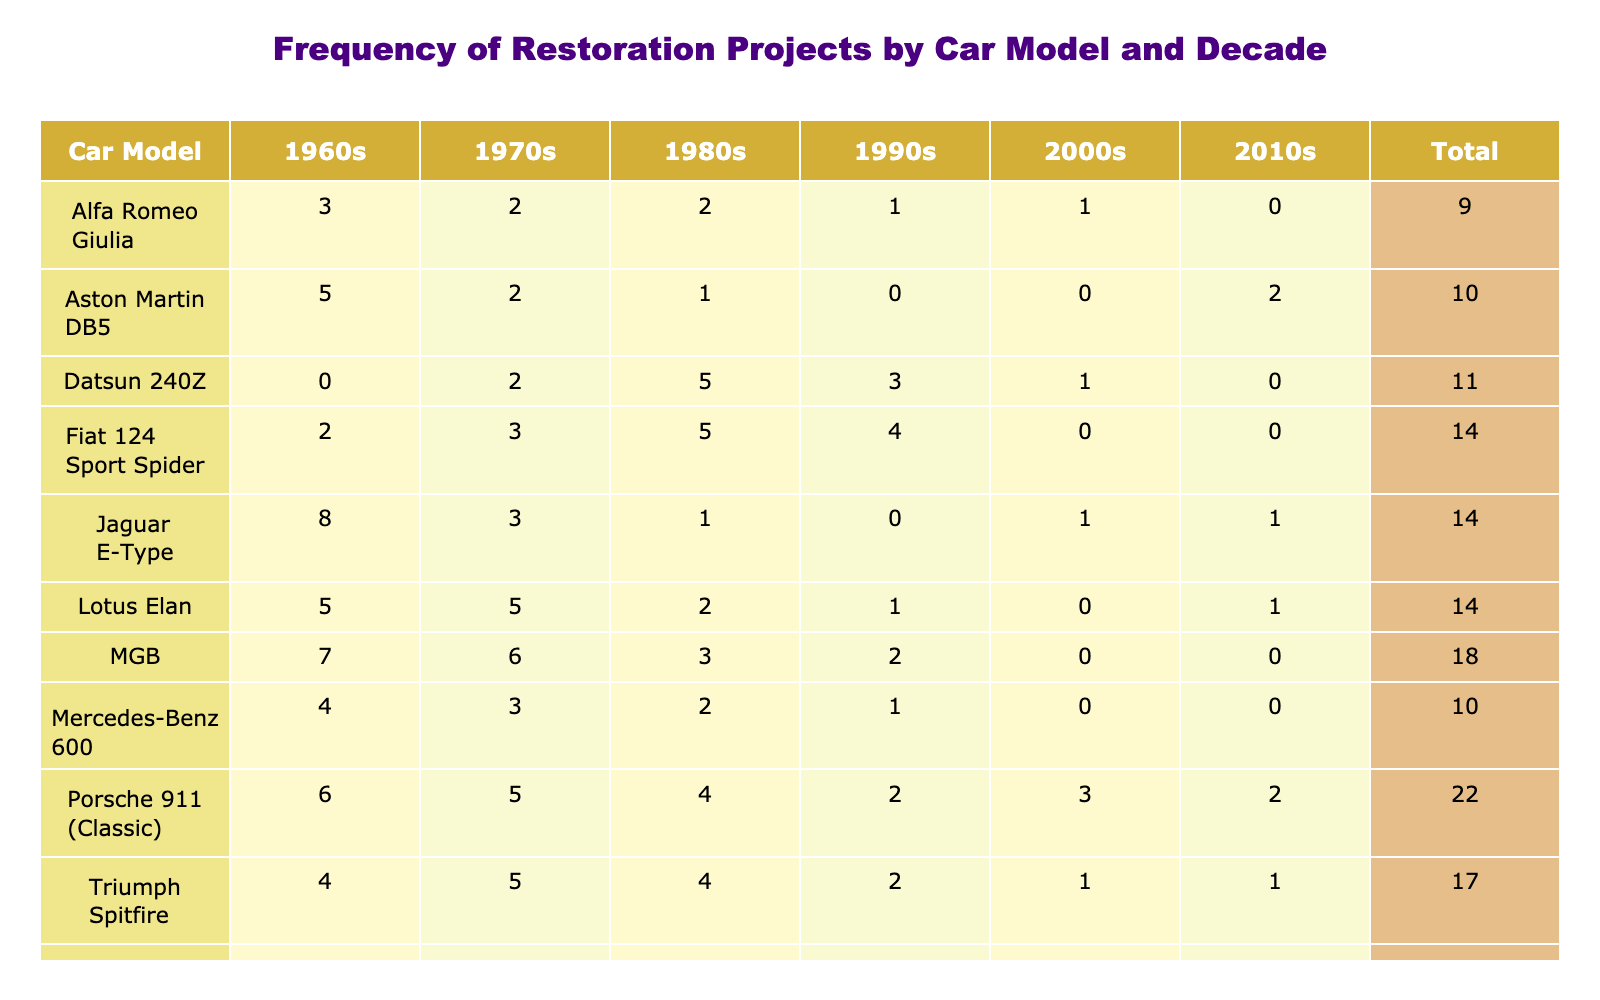What car model had the highest frequency of restoration projects in the 1960s? The values in the 1960s column are compared for each car model. The highest value is 8, which corresponds to the Jaguar E-Type.
Answer: Jaguar E-Type How many restoration projects were completed for the Aston Martin DB5 in total? To find the total for the Aston Martin DB5, sum all the values in its row: 5 + 2 + 1 + 0 + 0 + 2 = 10.
Answer: 10 Did the Mercedes-Benz 600 have more restoration projects in the 1970s than in the 1990s? The value for the Mercedes-Benz 600 in the 1970s is 3 and in the 1990s is 1. Therefore, it did have more in the 1970s.
Answer: Yes What is the average number of restoration projects for the Porsche 911 (Classic) across all decades? Sum the values for Porsche 911 (Classic): 6 + 5 + 4 + 2 + 3 + 2 = 22. There are 6 decades, so the average is 22/6 = 3.67.
Answer: 3.67 Which car model had the least frequency of restoration projects in the 2000s? The values for the 2000s are compared, where the lowest is 0, corresponding to MGB, Lotus Elan, and Aston Martin DB5.
Answer: MGB, Lotus Elan, and Aston Martin DB5 What is the total number of restoration projects for all car models in the 1980s? To get the total for the 1980s, we add: 1 + 1 + 2 + 4 + 2 + 3 + 2 + 5 + 5 + 4 = 25.
Answer: 25 Did any car model have the same frequency of restoration projects over the decades 1990s and 2000s? Looking at the 1990s and 2000s columns, the values are compared: Aston Martin DB5 (0), Jaguar E-Type (1), Mercedes-Benz 600 (0), Porsche 911 (Classic) (3), Alfa Romeo Giulia (1), MGB (0), Lotus Elan (0), Datsun 240Z (1), Fiat 124 Sport Spider (0), Triumph Spitfire (1). There are several matches: Aston Martin DB5, MGB, Lotus Elan, and Fiat 124 Sport Spider had both 0.
Answer: Yes What is the difference in the total number of restoration projects between Datsun 240Z and Triumph Spitfire? The totals for Datsun 240Z is 11 (0 + 2 + 5 + 3 + 1 + 0) and for Triumph Spitfire is 17 (4 + 5 + 4 + 2 + 1 + 1), hence the difference is 17 - 11 = 6.
Answer: 6 Which model had the highest restoration frequency in any decade? Each maximum value of the columns is noted: 8 for Jaguar E-Type (1960s). No other model surpassed this peak across all decades.
Answer: Jaguar E-Type 